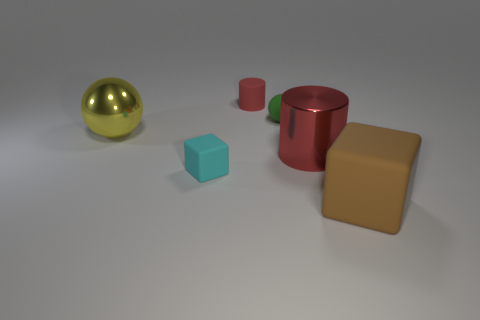How many tiny red objects have the same shape as the yellow object? There are no tiny red objects that have the same spherical shape as the yellow object. The red object in the image is a cylinder, which is a different shape. 